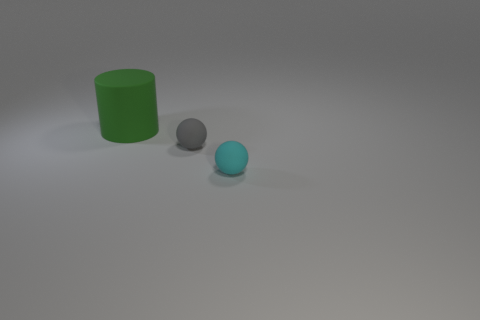Are there any rubber objects that are left of the sphere to the left of the cyan thing?
Ensure brevity in your answer.  Yes. There is a gray thing; does it have the same size as the matte ball that is in front of the small gray rubber ball?
Your response must be concise. Yes. Is there a thing that is behind the small thing that is in front of the ball that is to the left of the cyan thing?
Your response must be concise. Yes. Does the cylinder have the same size as the cyan object?
Offer a terse response. No. There is a rubber thing that is both behind the cyan object and in front of the large rubber cylinder; what color is it?
Your answer should be very brief. Gray. There is another small thing that is the same material as the tiny cyan object; what is its shape?
Keep it short and to the point. Sphere. How many matte things are behind the small cyan rubber object and to the right of the large object?
Your response must be concise. 1. There is a large green rubber thing; are there any cyan balls in front of it?
Offer a terse response. Yes. Is the shape of the tiny object behind the cyan object the same as the thing to the right of the gray rubber sphere?
Your answer should be compact. Yes. How many things are either gray matte objects or matte things that are in front of the large green thing?
Ensure brevity in your answer.  2. 